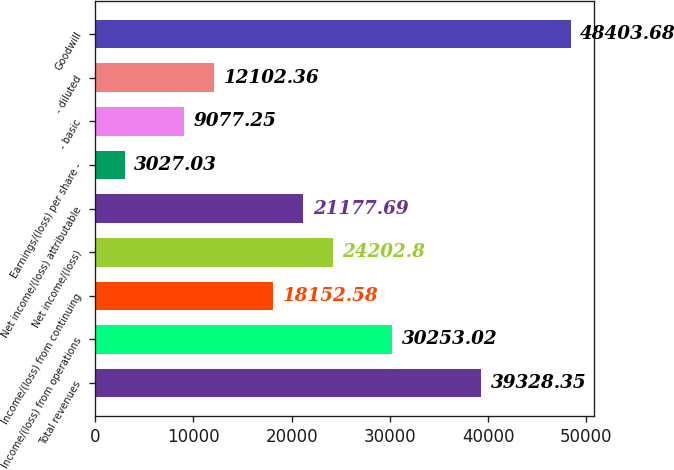Convert chart. <chart><loc_0><loc_0><loc_500><loc_500><bar_chart><fcel>Total revenues<fcel>Income/(loss) from operations<fcel>Income/(loss) from continuing<fcel>Net income/(loss)<fcel>Net income/(loss) attributable<fcel>Earnings/(loss) per share -<fcel>- basic<fcel>- diluted<fcel>Goodwill<nl><fcel>39328.3<fcel>30253<fcel>18152.6<fcel>24202.8<fcel>21177.7<fcel>3027.03<fcel>9077.25<fcel>12102.4<fcel>48403.7<nl></chart> 